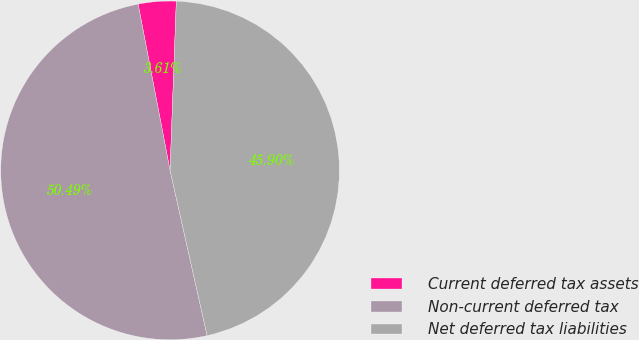Convert chart to OTSL. <chart><loc_0><loc_0><loc_500><loc_500><pie_chart><fcel>Current deferred tax assets<fcel>Non-current deferred tax<fcel>Net deferred tax liabilities<nl><fcel>3.61%<fcel>50.49%<fcel>45.9%<nl></chart> 